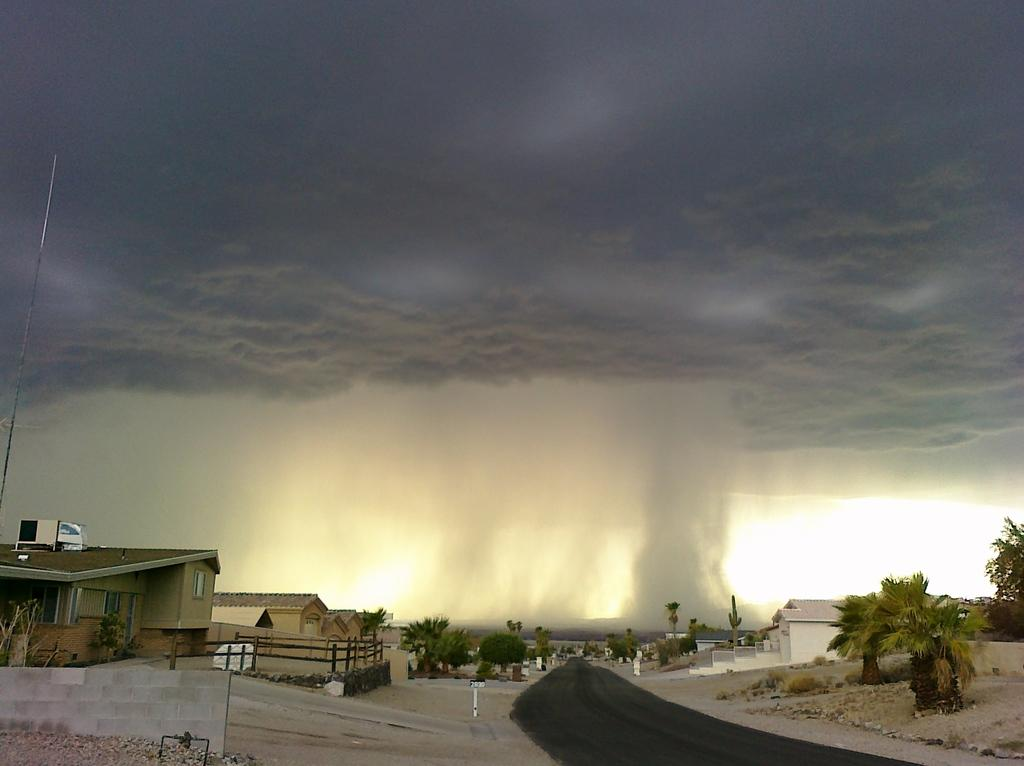What type of natural elements can be seen in the image? There are trees in the image. What type of man-made structures are present in the image? There are buildings in the image. What are the vertical structures in the image used for? The poles in the image are likely used for supporting wires or signs. What type of transportation infrastructure is visible in the image? There is a road in the image. What is the weather like in the background of the image? It appears to be raining in the background of the image. What is visible in the sky in the background of the image? The sky is visible in the background of the image. How many daughters are present in the image? There are no daughters visible in the image. What type of chairs are used during the feast in the image? There is no feast or chairs present in the image. 